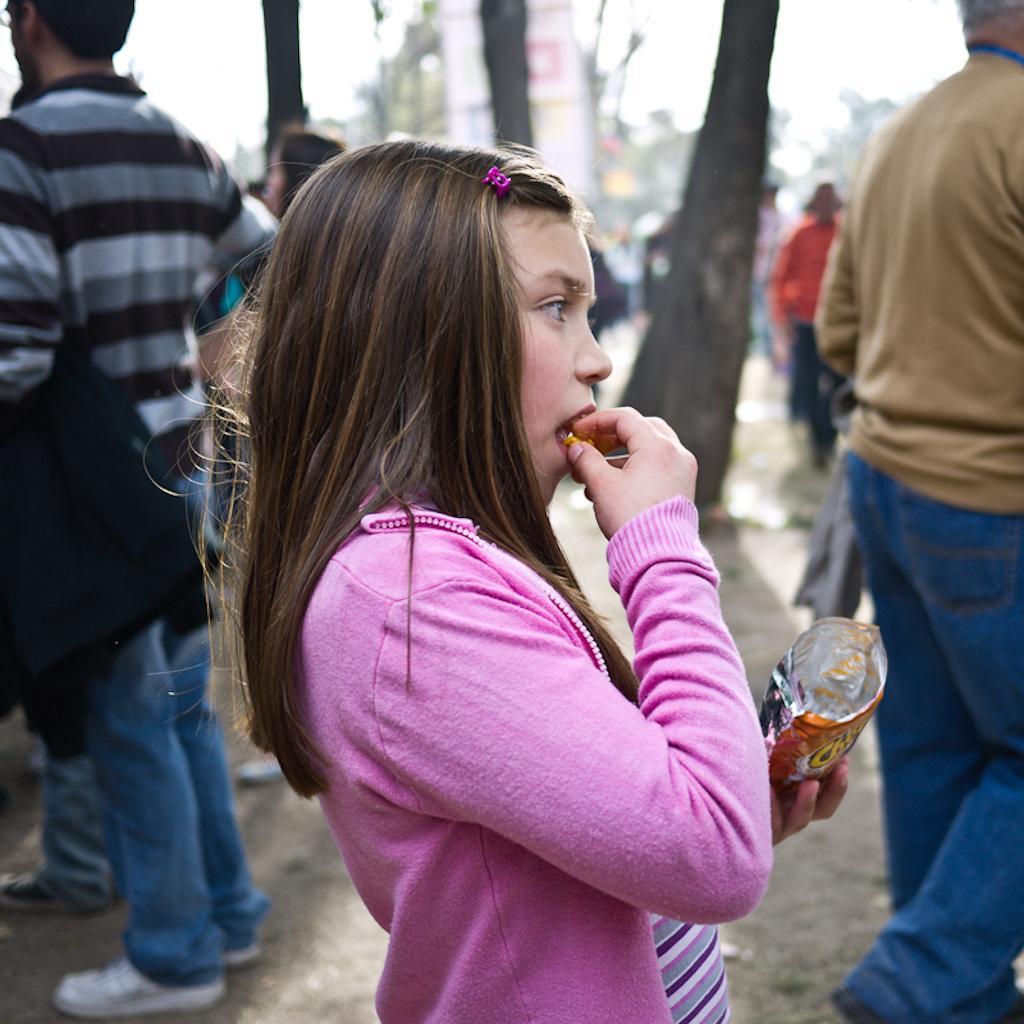How would you summarize this image in a sentence or two? Here in this picture, in the middle we can see a child standing over a place and eating something from the packet present in her hand and beside her also we can see other number of people standing and walking over the place and we can see the trees and other things in blurry manner. 